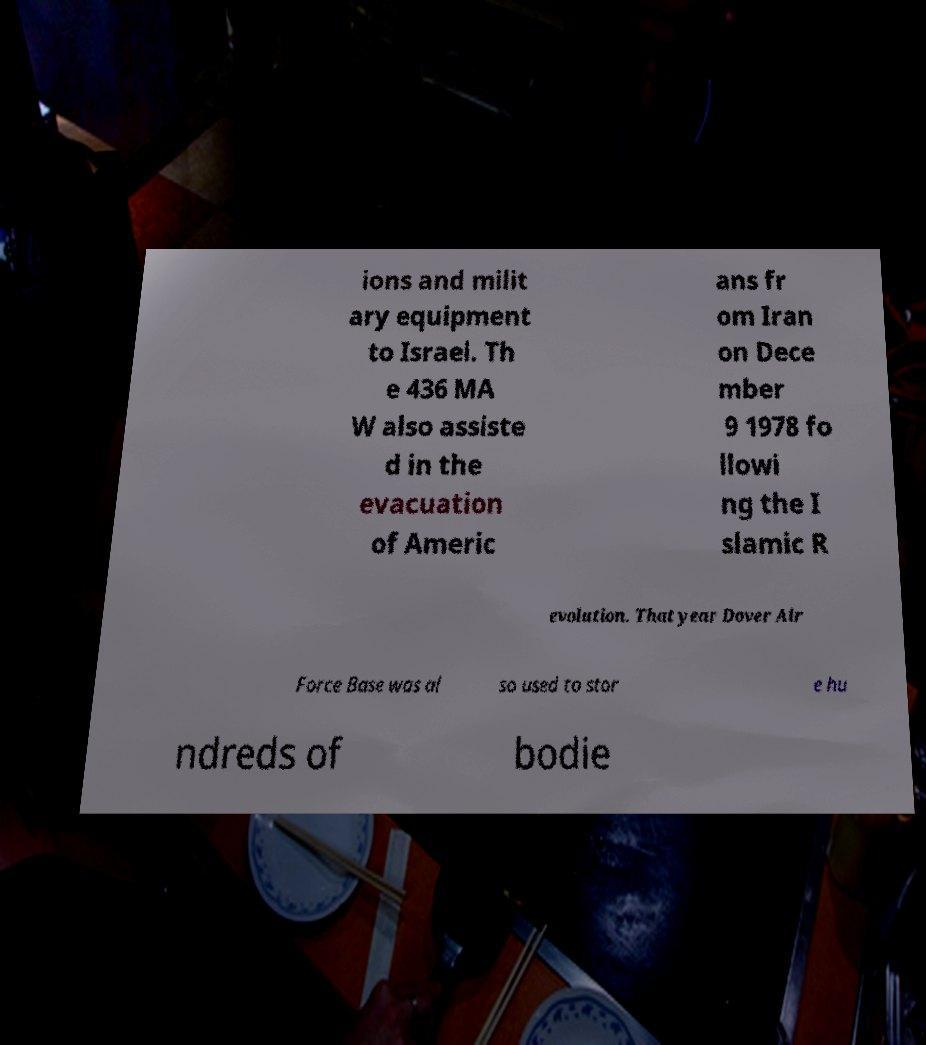Please identify and transcribe the text found in this image. ions and milit ary equipment to Israel. Th e 436 MA W also assiste d in the evacuation of Americ ans fr om Iran on Dece mber 9 1978 fo llowi ng the I slamic R evolution. That year Dover Air Force Base was al so used to stor e hu ndreds of bodie 